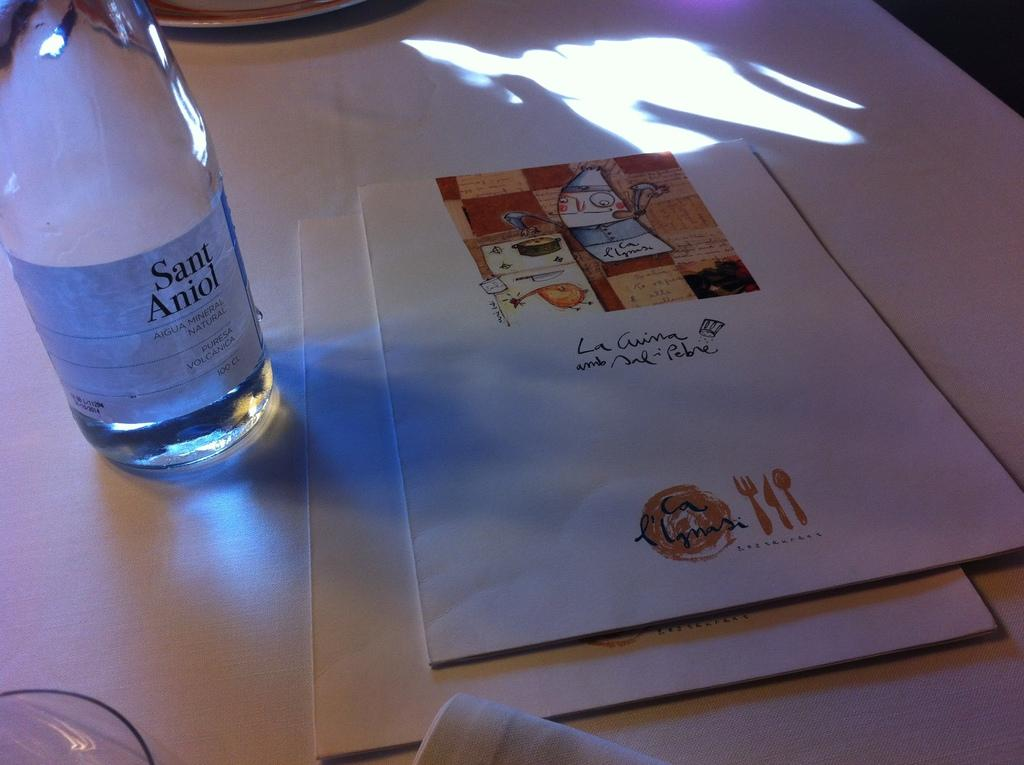What is the color of the bottle in the image? The bottle in the image is white. Where is the bottle located? The bottle is kept on a table. What else can be seen on the table in the image? There are menu cards in the image. What is the name of the menu cards? The menu cards are named "La Ligma." How many tails can be seen on the menu cards in the image? There are no tails present on the menu cards in the image. 